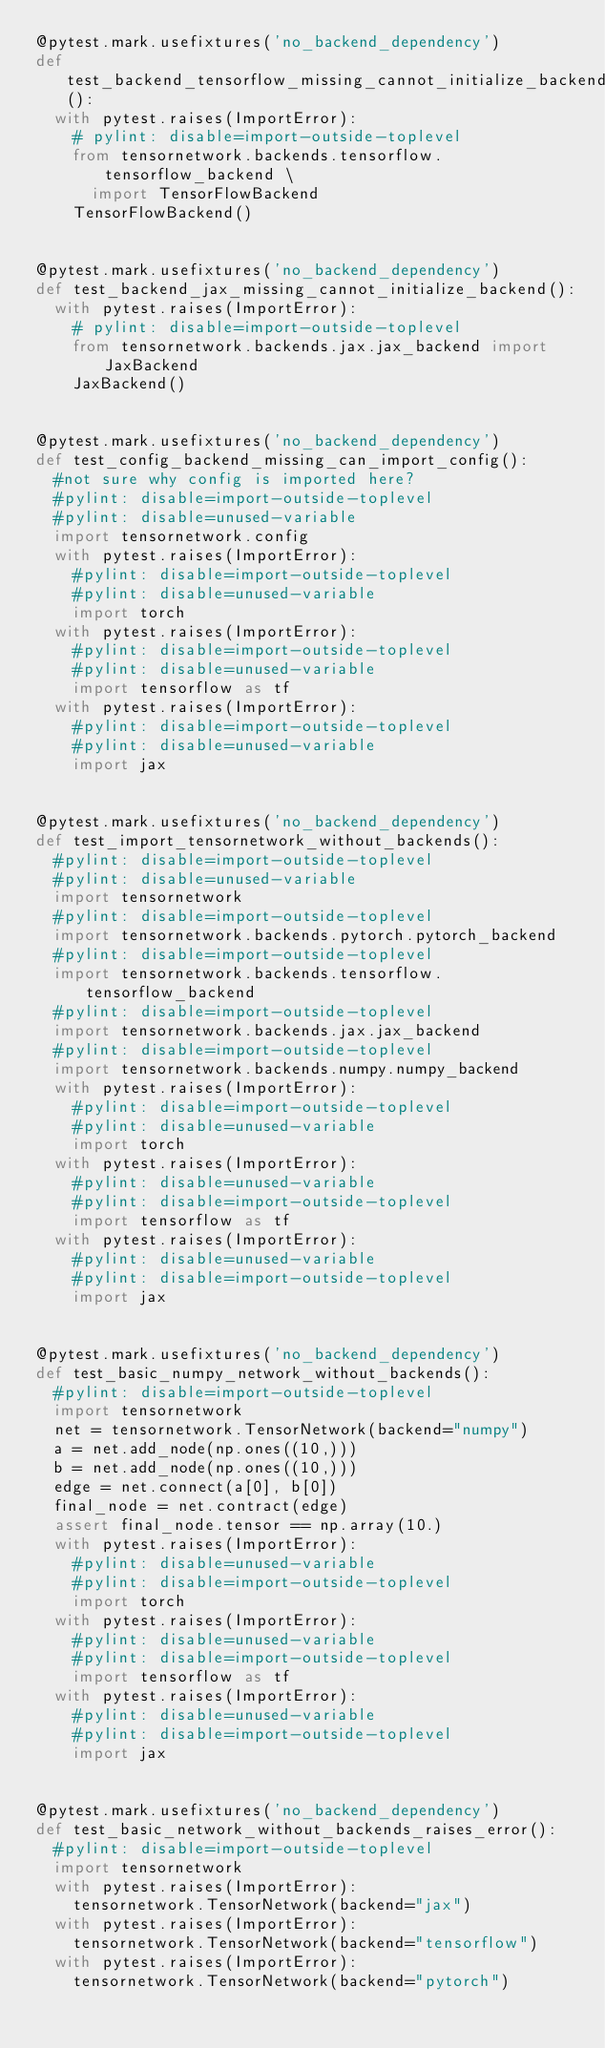Convert code to text. <code><loc_0><loc_0><loc_500><loc_500><_Python_>@pytest.mark.usefixtures('no_backend_dependency')
def test_backend_tensorflow_missing_cannot_initialize_backend():
  with pytest.raises(ImportError):
    # pylint: disable=import-outside-toplevel
    from tensornetwork.backends.tensorflow.tensorflow_backend \
      import TensorFlowBackend
    TensorFlowBackend()


@pytest.mark.usefixtures('no_backend_dependency')
def test_backend_jax_missing_cannot_initialize_backend():
  with pytest.raises(ImportError):
    # pylint: disable=import-outside-toplevel
    from tensornetwork.backends.jax.jax_backend import JaxBackend
    JaxBackend()


@pytest.mark.usefixtures('no_backend_dependency')
def test_config_backend_missing_can_import_config():
  #not sure why config is imported here?
  #pylint: disable=import-outside-toplevel
  #pylint: disable=unused-variable
  import tensornetwork.config
  with pytest.raises(ImportError):
    #pylint: disable=import-outside-toplevel
    #pylint: disable=unused-variable
    import torch
  with pytest.raises(ImportError):
    #pylint: disable=import-outside-toplevel
    #pylint: disable=unused-variable
    import tensorflow as tf
  with pytest.raises(ImportError):
    #pylint: disable=import-outside-toplevel
    #pylint: disable=unused-variable
    import jax


@pytest.mark.usefixtures('no_backend_dependency')
def test_import_tensornetwork_without_backends():
  #pylint: disable=import-outside-toplevel
  #pylint: disable=unused-variable
  import tensornetwork
  #pylint: disable=import-outside-toplevel
  import tensornetwork.backends.pytorch.pytorch_backend
  #pylint: disable=import-outside-toplevel
  import tensornetwork.backends.tensorflow.tensorflow_backend
  #pylint: disable=import-outside-toplevel
  import tensornetwork.backends.jax.jax_backend
  #pylint: disable=import-outside-toplevel
  import tensornetwork.backends.numpy.numpy_backend
  with pytest.raises(ImportError):
    #pylint: disable=import-outside-toplevel
    #pylint: disable=unused-variable
    import torch
  with pytest.raises(ImportError):
    #pylint: disable=unused-variable
    #pylint: disable=import-outside-toplevel
    import tensorflow as tf
  with pytest.raises(ImportError):
    #pylint: disable=unused-variable
    #pylint: disable=import-outside-toplevel
    import jax


@pytest.mark.usefixtures('no_backend_dependency')
def test_basic_numpy_network_without_backends():
  #pylint: disable=import-outside-toplevel
  import tensornetwork
  net = tensornetwork.TensorNetwork(backend="numpy")
  a = net.add_node(np.ones((10,)))
  b = net.add_node(np.ones((10,)))
  edge = net.connect(a[0], b[0])
  final_node = net.contract(edge)
  assert final_node.tensor == np.array(10.)
  with pytest.raises(ImportError):
    #pylint: disable=unused-variable
    #pylint: disable=import-outside-toplevel
    import torch
  with pytest.raises(ImportError):
    #pylint: disable=unused-variable
    #pylint: disable=import-outside-toplevel
    import tensorflow as tf
  with pytest.raises(ImportError):
    #pylint: disable=unused-variable
    #pylint: disable=import-outside-toplevel
    import jax


@pytest.mark.usefixtures('no_backend_dependency')
def test_basic_network_without_backends_raises_error():
  #pylint: disable=import-outside-toplevel
  import tensornetwork
  with pytest.raises(ImportError):
    tensornetwork.TensorNetwork(backend="jax")
  with pytest.raises(ImportError):
    tensornetwork.TensorNetwork(backend="tensorflow")
  with pytest.raises(ImportError):
    tensornetwork.TensorNetwork(backend="pytorch")
</code> 